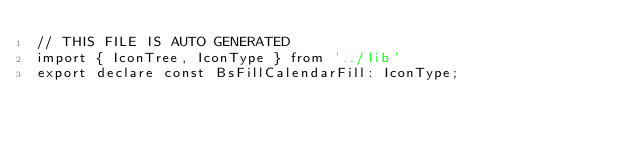<code> <loc_0><loc_0><loc_500><loc_500><_TypeScript_>// THIS FILE IS AUTO GENERATED
import { IconTree, IconType } from '../lib'
export declare const BsFillCalendarFill: IconType;
</code> 